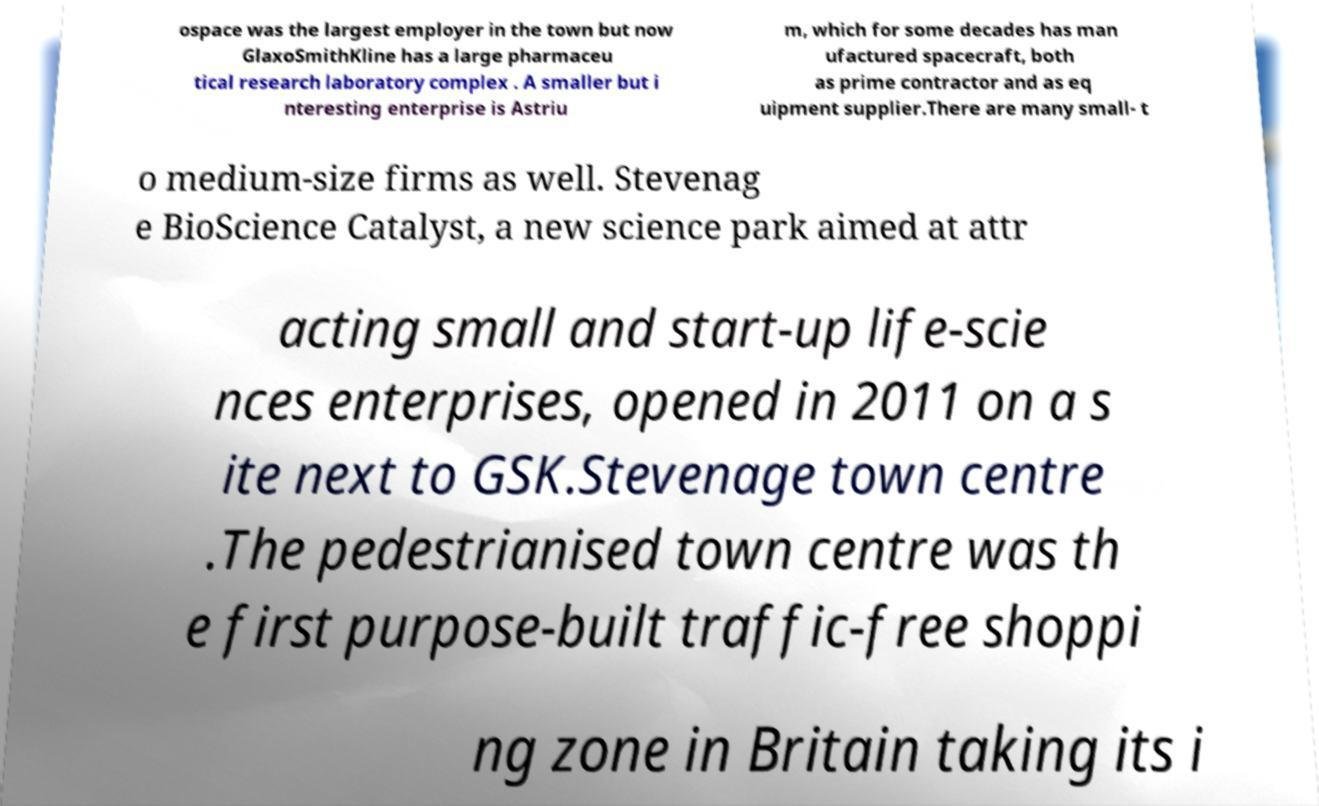Could you extract and type out the text from this image? ospace was the largest employer in the town but now GlaxoSmithKline has a large pharmaceu tical research laboratory complex . A smaller but i nteresting enterprise is Astriu m, which for some decades has man ufactured spacecraft, both as prime contractor and as eq uipment supplier.There are many small- t o medium-size firms as well. Stevenag e BioScience Catalyst, a new science park aimed at attr acting small and start-up life-scie nces enterprises, opened in 2011 on a s ite next to GSK.Stevenage town centre .The pedestrianised town centre was th e first purpose-built traffic-free shoppi ng zone in Britain taking its i 